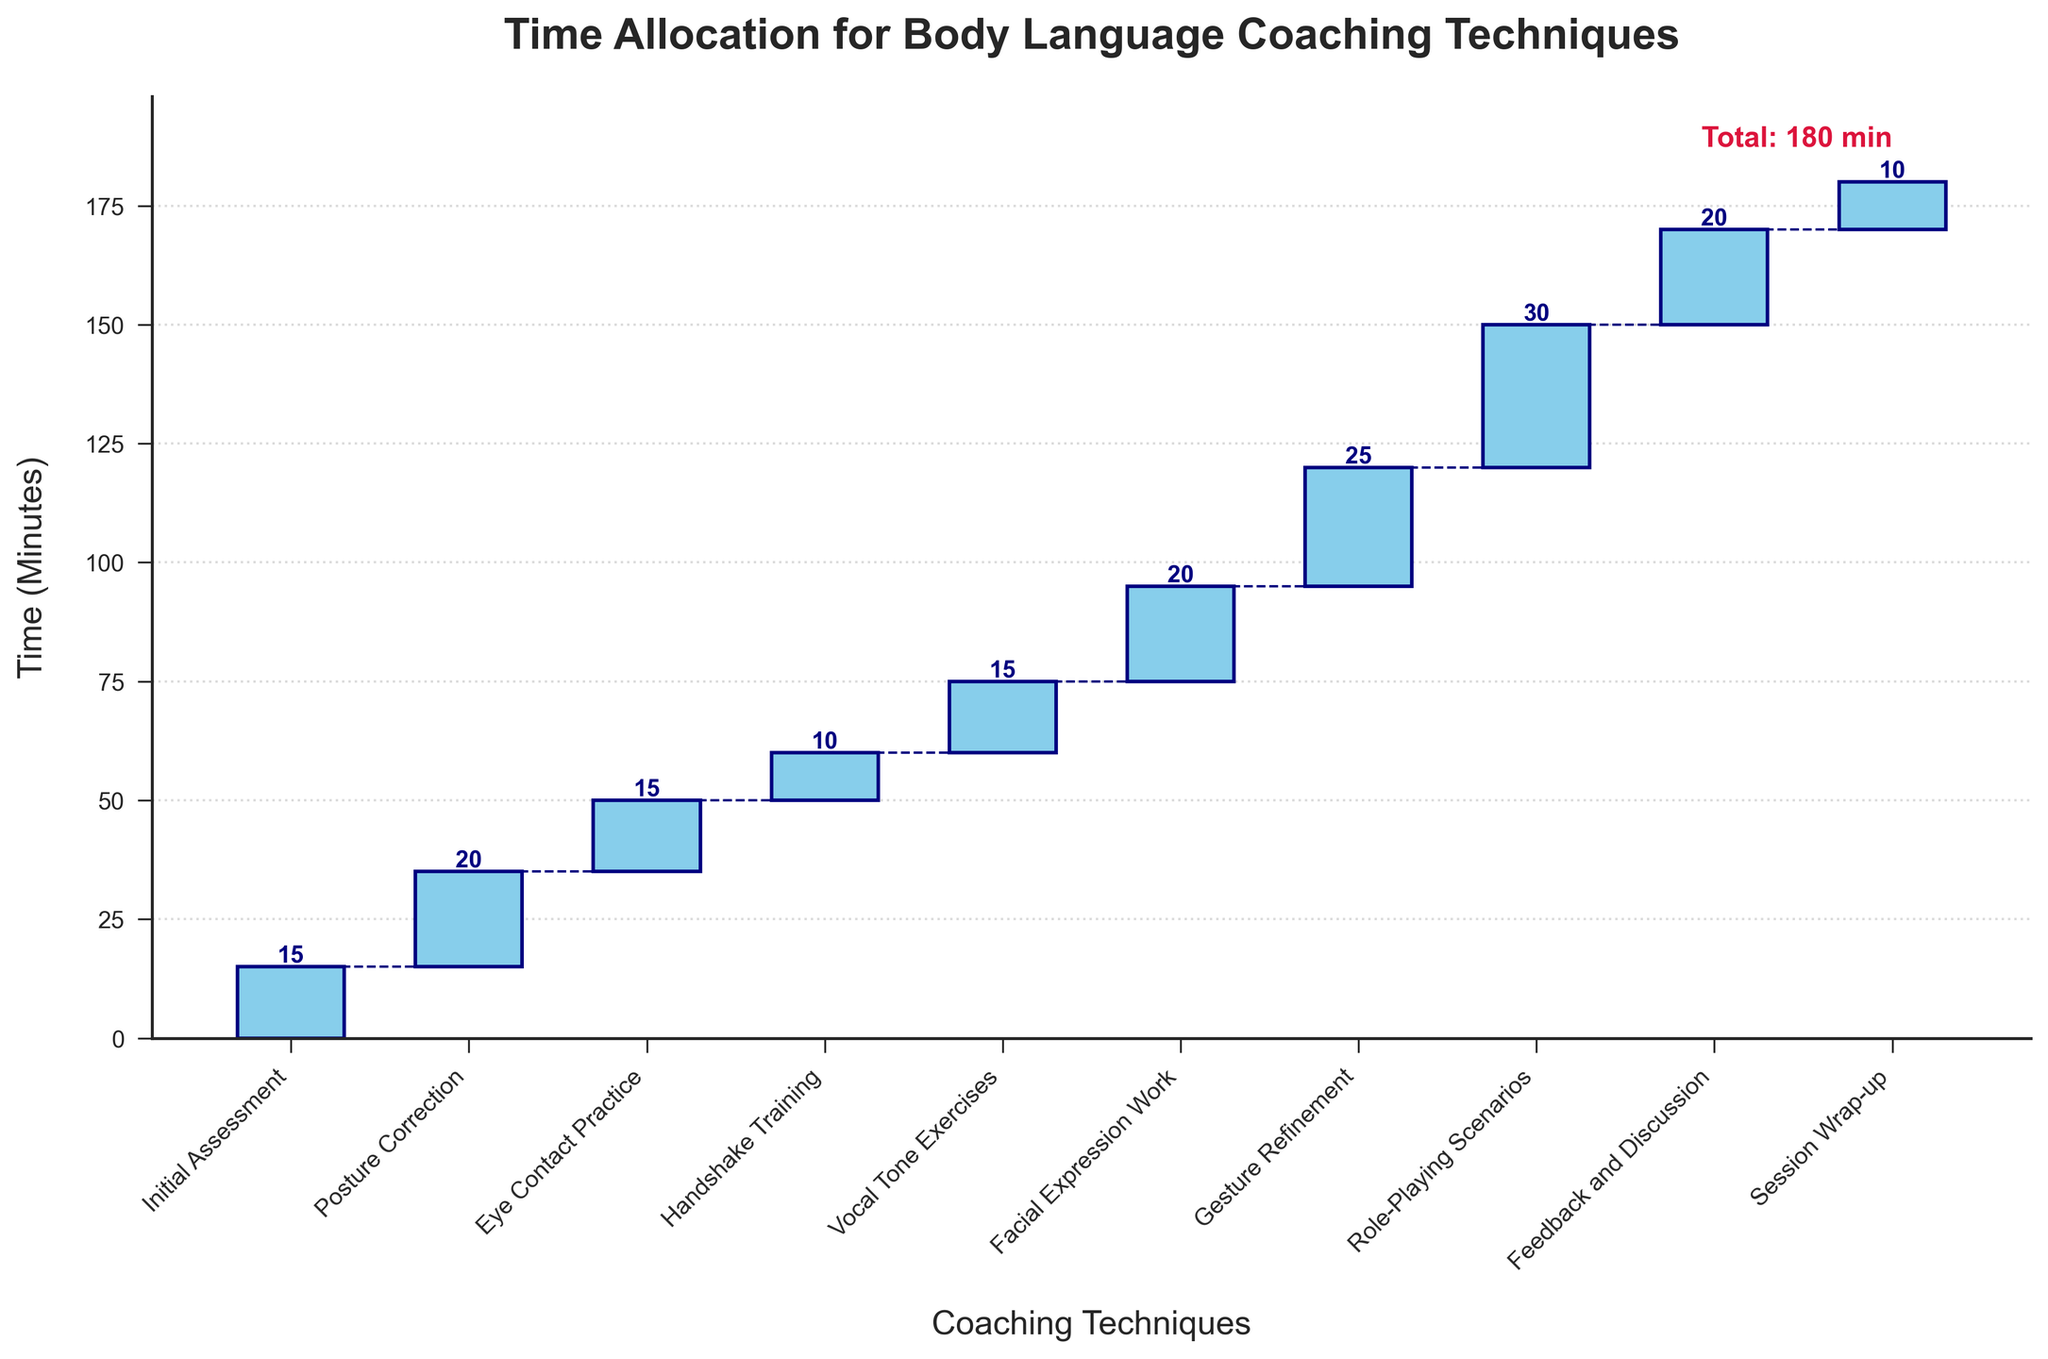What is the total time spent on Gesture Refinement? Gesture Refinement takes up 25 minutes. This information is shown directly on the figure where "Gesture Refinement" is labeled.
Answer: 25 minutes How much time is allocated to both Vocal Tone Exercises and Eye Contact Practice combined? Vocal Tone Exercises take 15 minutes and Eye Contact Practice also takes 15 minutes. Adding these together gives a total of 30 minutes.
Answer: 30 minutes Which coaching technique takes the highest amount of time? Role-Playing Scenarios take up 30 minutes, which is the highest amount of time allocated to any technique. This is evident as its bar is the tallest in the figure.
Answer: Role-Playing Scenarios How does the time spent on Posture Correction compare to that on Facial Expression Work? Posture Correction takes 20 minutes, while Facial Expression Work also takes 20 minutes. This means both techniques take the same amount of time.
Answer: They are equal What is the cumulative time spent from Initial Assessment to Vocal Tone Exercises? The time spent from Initial Assessment (15 min) to Vocal Tone Exercises (15 min) is calculated by summing the times for Initial Assessment: 15 min, Posture Correction: 20 min, Eye Contact Practice: 15 min, Handshake Training: 10 min, and Vocal Tone Exercises: 15 min. The total is 15 + 20 + 15 + 10 + 15 = 75 min.
Answer: 75 minutes What is the shortest time allocated to any technique, and which technique is it? The shortest time allocated is 10 minutes, which is for both Handshake Training and Session Wrap-up. This is visible from their bars in the figure.
Answer: 10 minutes, Handshake Training and Session Wrap-up What percentage of the total time is allocated to Role-Playing Scenarios? The total time for all techniques is 190 minutes. Role-Playing Scenarios take 30 minutes. To find the percentage, we use the formula (30/190) * 100%. Calculation: (30/190) * 100% ≈ 15.79%.
Answer: Approximately 15.79% How much longer is the time spent on Gesture Refinement compared to Handshake Training? Time spent on Gesture Refinement is 25 minutes, and Handshake Training is 10 minutes. The difference is calculated as 25 - 10 = 15 minutes.
Answer: 15 minutes What is the average time spent per technique? The total time spent is 190 minutes and there are 10 techniques. The average is calculated by dividing the total time by the number of techniques: 190 / 10 = 19 minutes per technique.
Answer: 19 minutes 